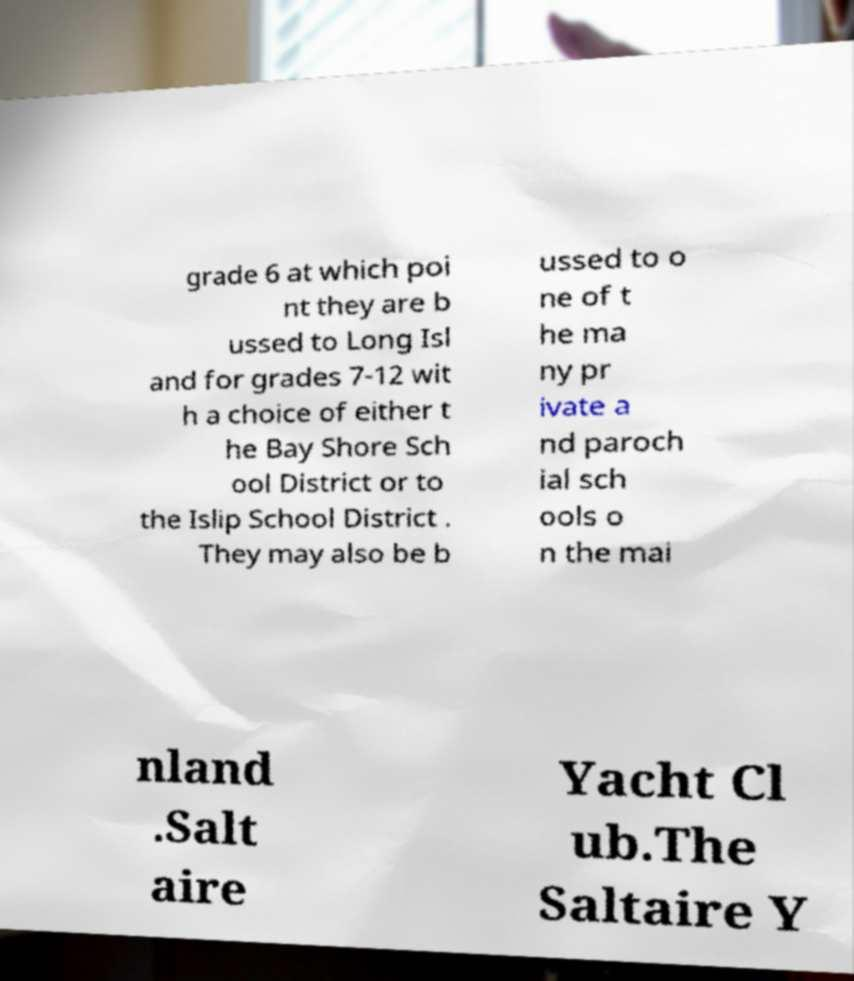Can you read and provide the text displayed in the image?This photo seems to have some interesting text. Can you extract and type it out for me? grade 6 at which poi nt they are b ussed to Long Isl and for grades 7-12 wit h a choice of either t he Bay Shore Sch ool District or to the Islip School District . They may also be b ussed to o ne of t he ma ny pr ivate a nd paroch ial sch ools o n the mai nland .Salt aire Yacht Cl ub.The Saltaire Y 